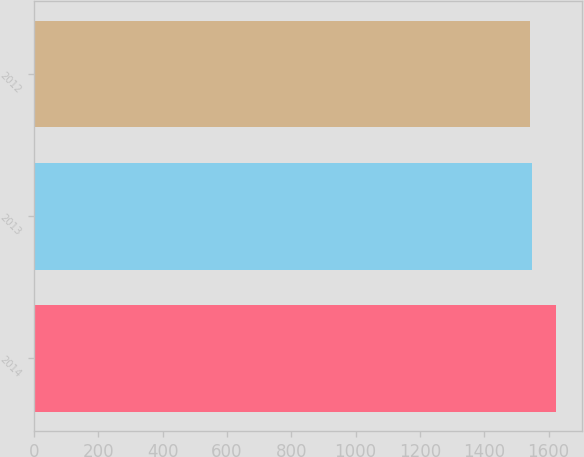Convert chart to OTSL. <chart><loc_0><loc_0><loc_500><loc_500><bar_chart><fcel>2014<fcel>2013<fcel>2012<nl><fcel>1623<fcel>1549.2<fcel>1541<nl></chart> 